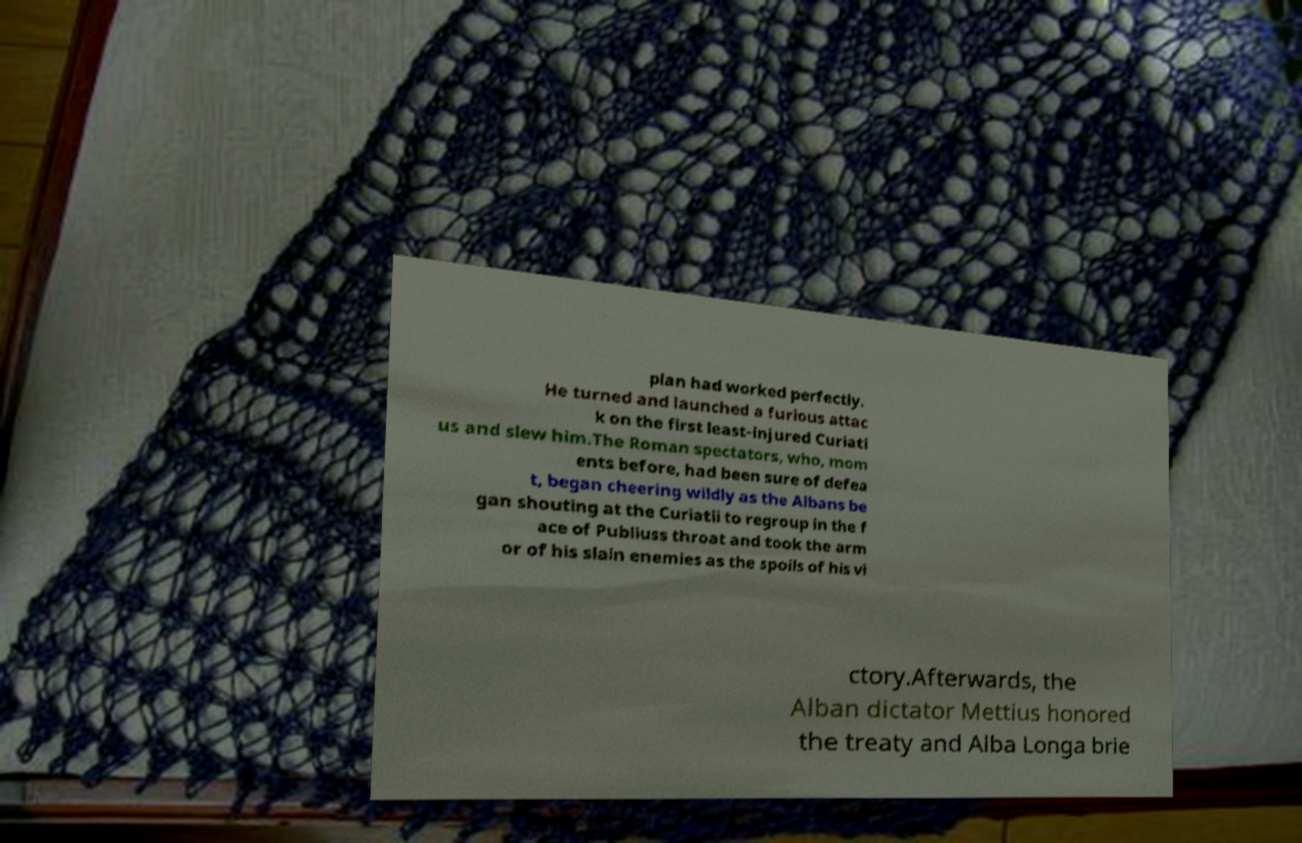Please read and relay the text visible in this image. What does it say? plan had worked perfectly. He turned and launched a furious attac k on the first least-injured Curiati us and slew him.The Roman spectators, who, mom ents before, had been sure of defea t, began cheering wildly as the Albans be gan shouting at the Curiatii to regroup in the f ace of Publiuss throat and took the arm or of his slain enemies as the spoils of his vi ctory.Afterwards, the Alban dictator Mettius honored the treaty and Alba Longa brie 